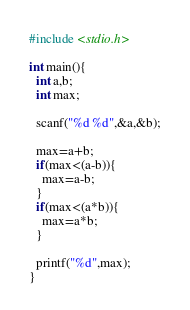<code> <loc_0><loc_0><loc_500><loc_500><_C_>#include <stdio.h>
 
int main(){
  int a,b;
  int max;
  
  scanf("%d %d",&a,&b);
  
  max=a+b;
  if(max<(a-b)){
    max=a-b;
  }
  if(max<(a*b)){
    max=a*b;
  }
  
  printf("%d",max);
}</code> 